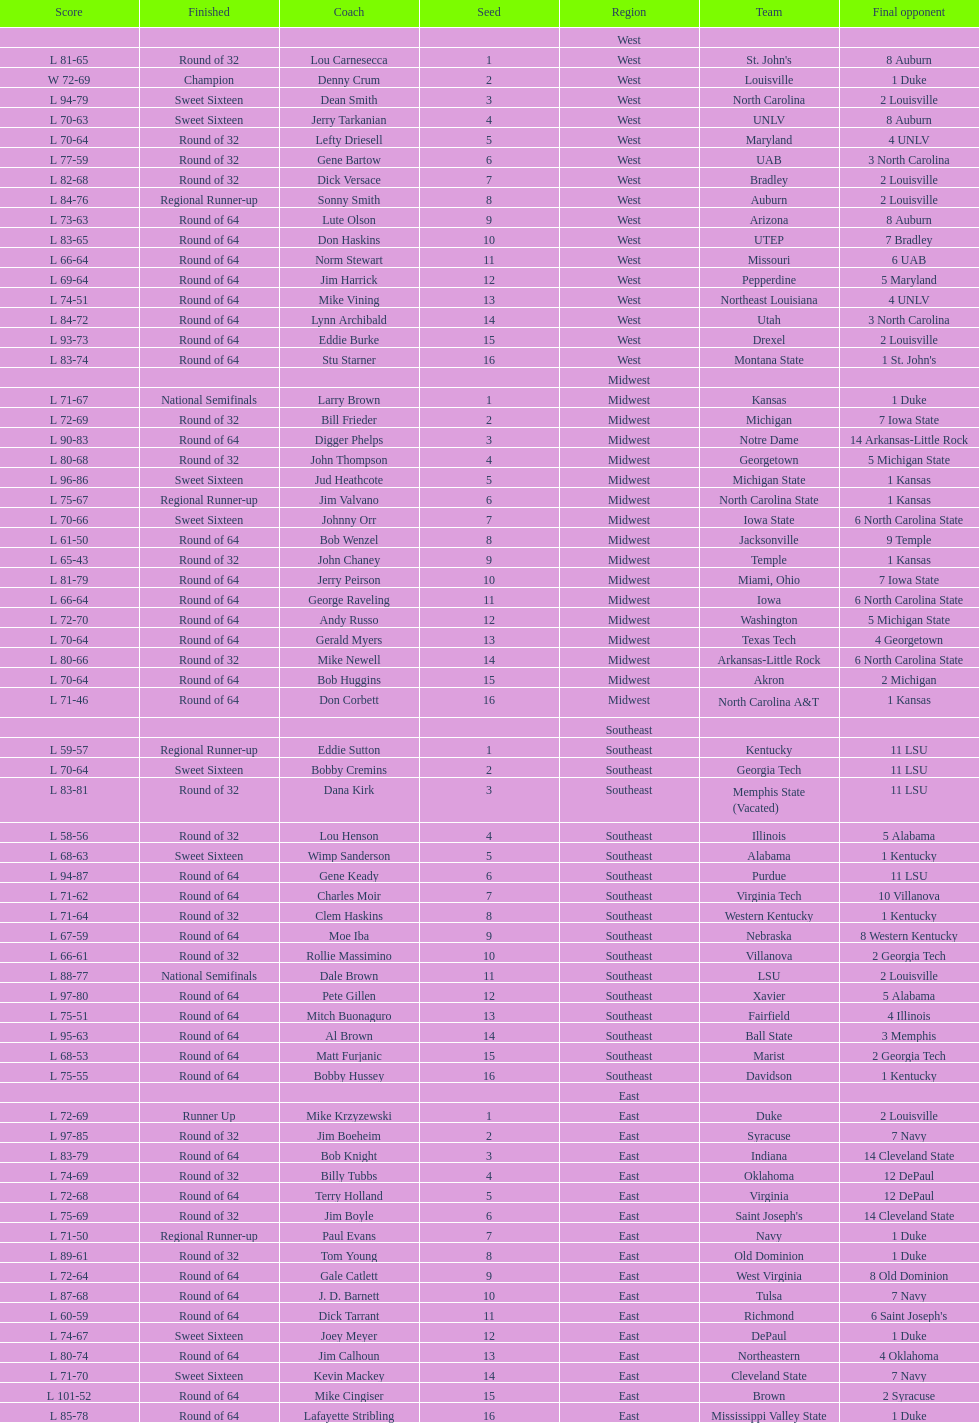Who is the only team from the east region to reach the final round? Duke. 